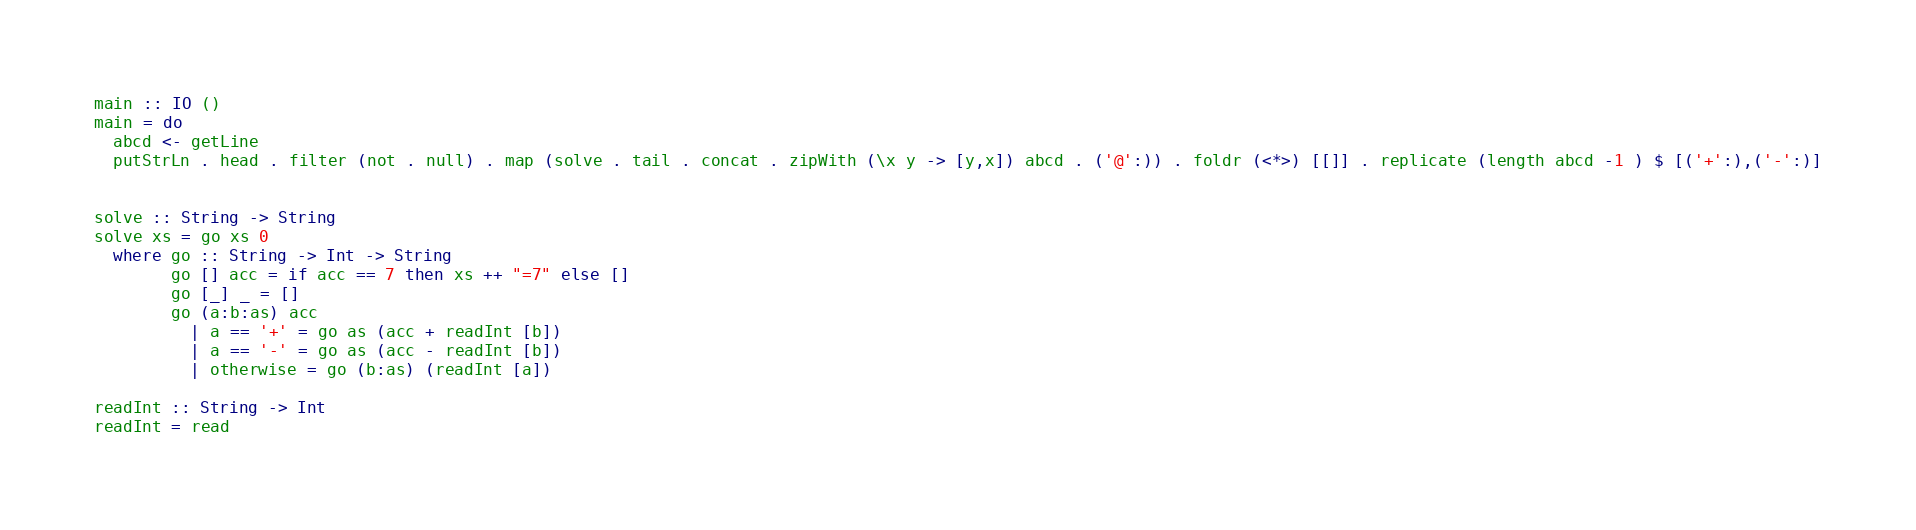Convert code to text. <code><loc_0><loc_0><loc_500><loc_500><_Haskell_>main :: IO ()
main = do
  abcd <- getLine
  putStrLn . head . filter (not . null) . map (solve . tail . concat . zipWith (\x y -> [y,x]) abcd . ('@':)) . foldr (<*>) [[]] . replicate (length abcd -1 ) $ [('+':),('-':)]


solve :: String -> String
solve xs = go xs 0
  where go :: String -> Int -> String
        go [] acc = if acc == 7 then xs ++ "=7" else []
        go [_] _ = []
        go (a:b:as) acc
          | a == '+' = go as (acc + readInt [b])
          | a == '-' = go as (acc - readInt [b])
          | otherwise = go (b:as) (readInt [a])

readInt :: String -> Int
readInt = read
</code> 